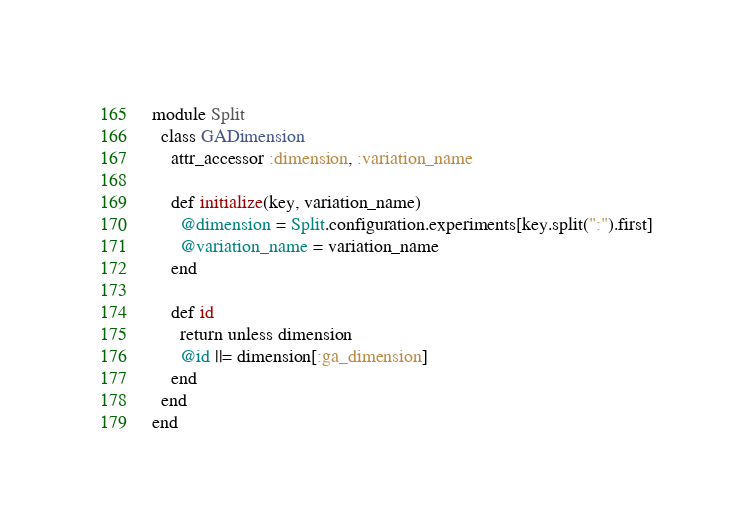Convert code to text. <code><loc_0><loc_0><loc_500><loc_500><_Ruby_>module Split
  class GADimension
    attr_accessor :dimension, :variation_name

    def initialize(key, variation_name)
      @dimension = Split.configuration.experiments[key.split(":").first]
      @variation_name = variation_name
    end

    def id
      return unless dimension
      @id ||= dimension[:ga_dimension]
    end
  end
end
</code> 